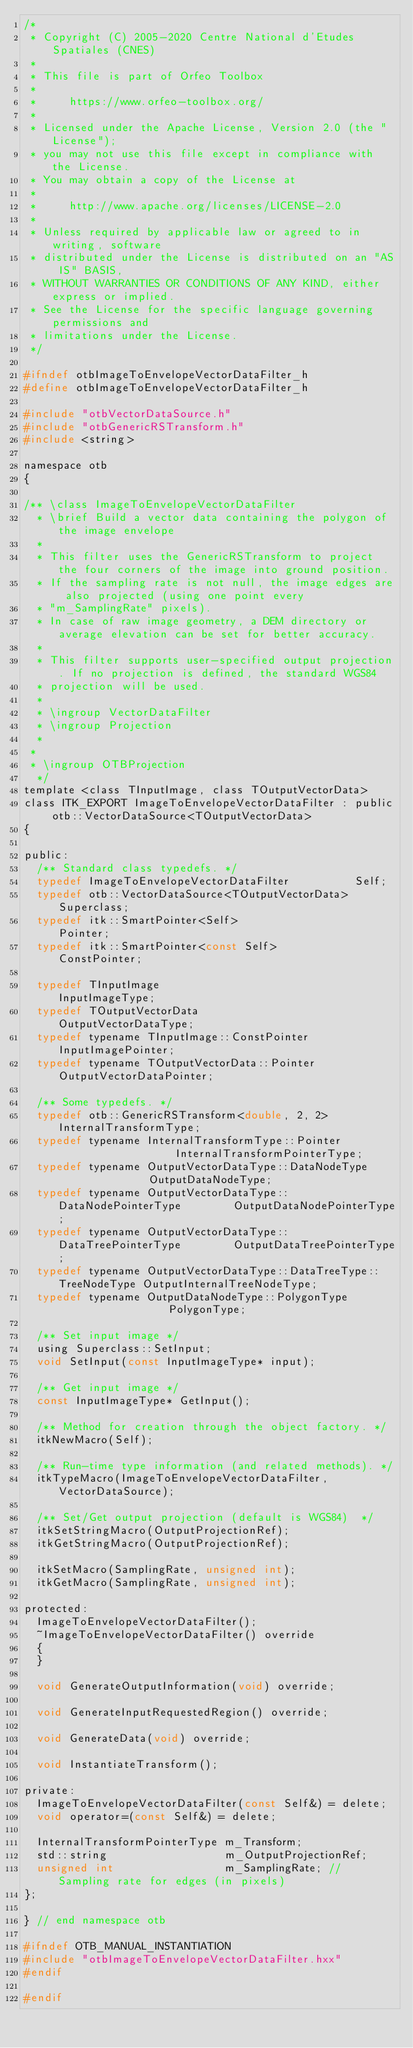<code> <loc_0><loc_0><loc_500><loc_500><_C_>/*
 * Copyright (C) 2005-2020 Centre National d'Etudes Spatiales (CNES)
 *
 * This file is part of Orfeo Toolbox
 *
 *     https://www.orfeo-toolbox.org/
 *
 * Licensed under the Apache License, Version 2.0 (the "License");
 * you may not use this file except in compliance with the License.
 * You may obtain a copy of the License at
 *
 *     http://www.apache.org/licenses/LICENSE-2.0
 *
 * Unless required by applicable law or agreed to in writing, software
 * distributed under the License is distributed on an "AS IS" BASIS,
 * WITHOUT WARRANTIES OR CONDITIONS OF ANY KIND, either express or implied.
 * See the License for the specific language governing permissions and
 * limitations under the License.
 */

#ifndef otbImageToEnvelopeVectorDataFilter_h
#define otbImageToEnvelopeVectorDataFilter_h

#include "otbVectorDataSource.h"
#include "otbGenericRSTransform.h"
#include <string>

namespace otb
{

/** \class ImageToEnvelopeVectorDataFilter
  * \brief Build a vector data containing the polygon of the image envelope
  *
  * This filter uses the GenericRSTransform to project the four corners of the image into ground position.
  * If the sampling rate is not null, the image edges are also projected (using one point every
  * "m_SamplingRate" pixels).
  * In case of raw image geometry, a DEM directory or average elevation can be set for better accuracy.
  *
  * This filter supports user-specified output projection. If no projection is defined, the standard WGS84
  * projection will be used.
  *
  * \ingroup VectorDataFilter
  * \ingroup Projection
  *
 *
 * \ingroup OTBProjection
  */
template <class TInputImage, class TOutputVectorData>
class ITK_EXPORT ImageToEnvelopeVectorDataFilter : public otb::VectorDataSource<TOutputVectorData>
{

public:
  /** Standard class typedefs. */
  typedef ImageToEnvelopeVectorDataFilter          Self;
  typedef otb::VectorDataSource<TOutputVectorData> Superclass;
  typedef itk::SmartPointer<Self>                  Pointer;
  typedef itk::SmartPointer<const Self>            ConstPointer;

  typedef TInputImage                         InputImageType;
  typedef TOutputVectorData                   OutputVectorDataType;
  typedef typename TInputImage::ConstPointer  InputImagePointer;
  typedef typename TOutputVectorData::Pointer OutputVectorDataPointer;

  /** Some typedefs. */
  typedef otb::GenericRSTransform<double, 2, 2> InternalTransformType;
  typedef typename InternalTransformType::Pointer                   InternalTransformPointerType;
  typedef typename OutputVectorDataType::DataNodeType               OutputDataNodeType;
  typedef typename OutputVectorDataType::DataNodePointerType        OutputDataNodePointerType;
  typedef typename OutputVectorDataType::DataTreePointerType        OutputDataTreePointerType;
  typedef typename OutputVectorDataType::DataTreeType::TreeNodeType OutputInternalTreeNodeType;
  typedef typename OutputDataNodeType::PolygonType                  PolygonType;

  /** Set input image */
  using Superclass::SetInput;
  void SetInput(const InputImageType* input);

  /** Get input image */
  const InputImageType* GetInput();

  /** Method for creation through the object factory. */
  itkNewMacro(Self);

  /** Run-time type information (and related methods). */
  itkTypeMacro(ImageToEnvelopeVectorDataFilter, VectorDataSource);

  /** Set/Get output projection (default is WGS84)  */
  itkSetStringMacro(OutputProjectionRef);
  itkGetStringMacro(OutputProjectionRef);

  itkSetMacro(SamplingRate, unsigned int);
  itkGetMacro(SamplingRate, unsigned int);

protected:
  ImageToEnvelopeVectorDataFilter();
  ~ImageToEnvelopeVectorDataFilter() override
  {
  }

  void GenerateOutputInformation(void) override;

  void GenerateInputRequestedRegion() override;

  void GenerateData(void) override;

  void InstantiateTransform();

private:
  ImageToEnvelopeVectorDataFilter(const Self&) = delete;
  void operator=(const Self&) = delete;

  InternalTransformPointerType m_Transform;
  std::string                  m_OutputProjectionRef;
  unsigned int                 m_SamplingRate; // Sampling rate for edges (in pixels)
};

} // end namespace otb

#ifndef OTB_MANUAL_INSTANTIATION
#include "otbImageToEnvelopeVectorDataFilter.hxx"
#endif

#endif
</code> 